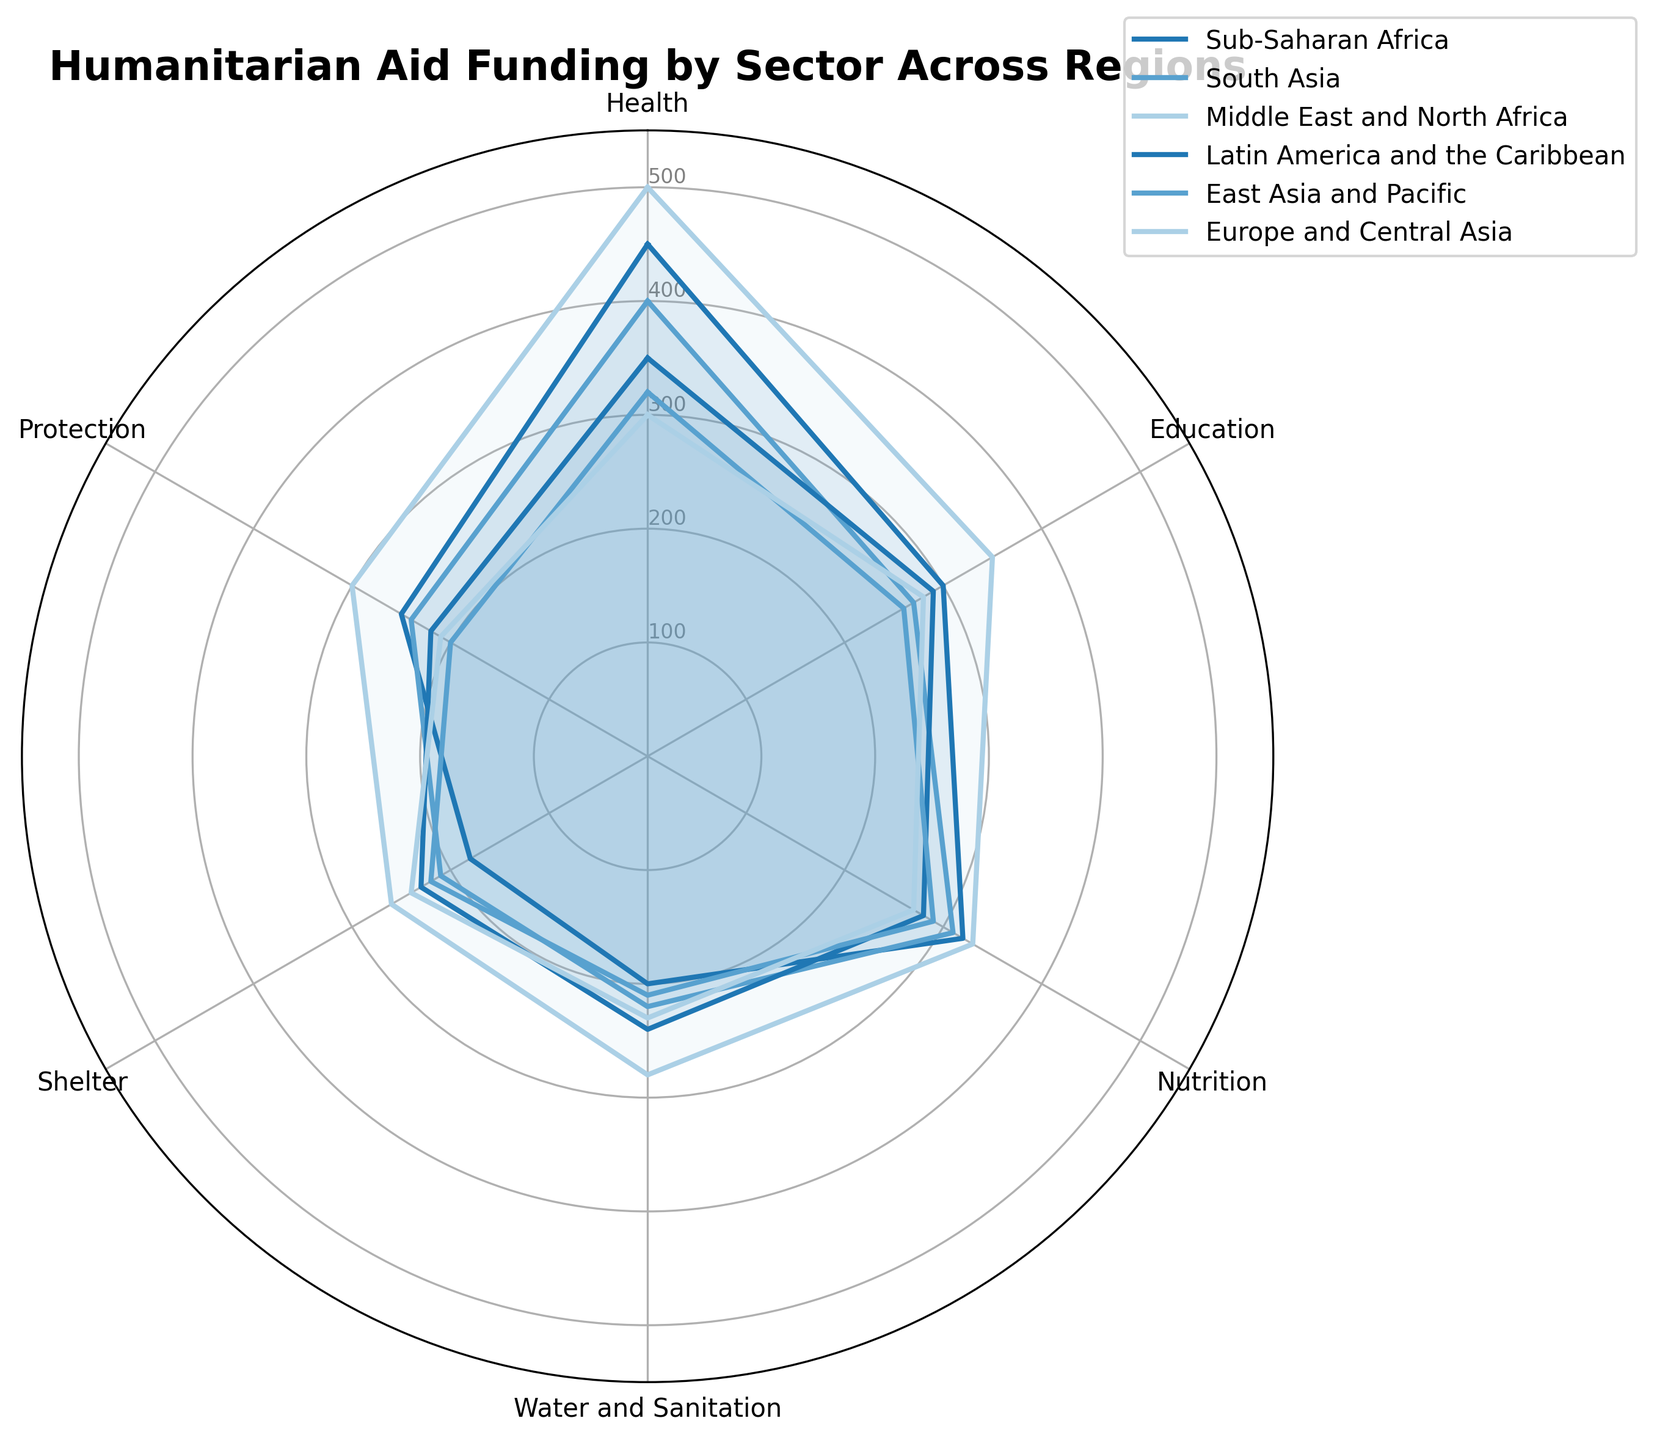Which region received the highest funding for Health? The figure shows a radar chart where each region has a value for Health funding. By looking at the outermost point on the Health sector, we see that the Middle East and North Africa (MENA) has the highest value at 500.
Answer: Middle East and North Africa Which regions have similar funding levels for Education? The radar chart allows us to compare the Education sectors across different regions. Sub-Saharan Africa has 300, and Latin America and the Caribbean has 290, which are very close to each other.
Answer: Sub-Saharan Africa and Latin America and the Caribbean Calculate the total funding for Water and Sanitation across all regions. To get the total funding, sum the values for Water and Sanitation across all regions: 200 (Sub-Saharan Africa) + 220 (South Asia) + 280 (MENA) + 240 (Latin America and the Caribbean) + 210 (East Asia and Pacific) + 230 (Europe and Central Asia). This equals 1380.
Answer: 1380 Which region has the lowest combined funding for Shelter and Protection? For each region, sum the values of Shelter and Protection and compare them. Sub-Saharan Africa: 180+250=430, South Asia: 210+240=450, MENA: 260+300=560, Latin America and the Caribbean: 230+220=450, East Asia and Pacific: 220+200=420, Europe and Central Asia: 240+210=450. The lowest combined funding is for East Asia and Pacific at 420.
Answer: East Asia and Pacific Which sector received the most even distribution of funding across all regions? Look at the radar chart for sectors where the funding values are relatively uniform. By comparing the sectors, we see that Protection seems to be the most evenly distributed across different regions, with values around 240-300.
Answer: Protection 